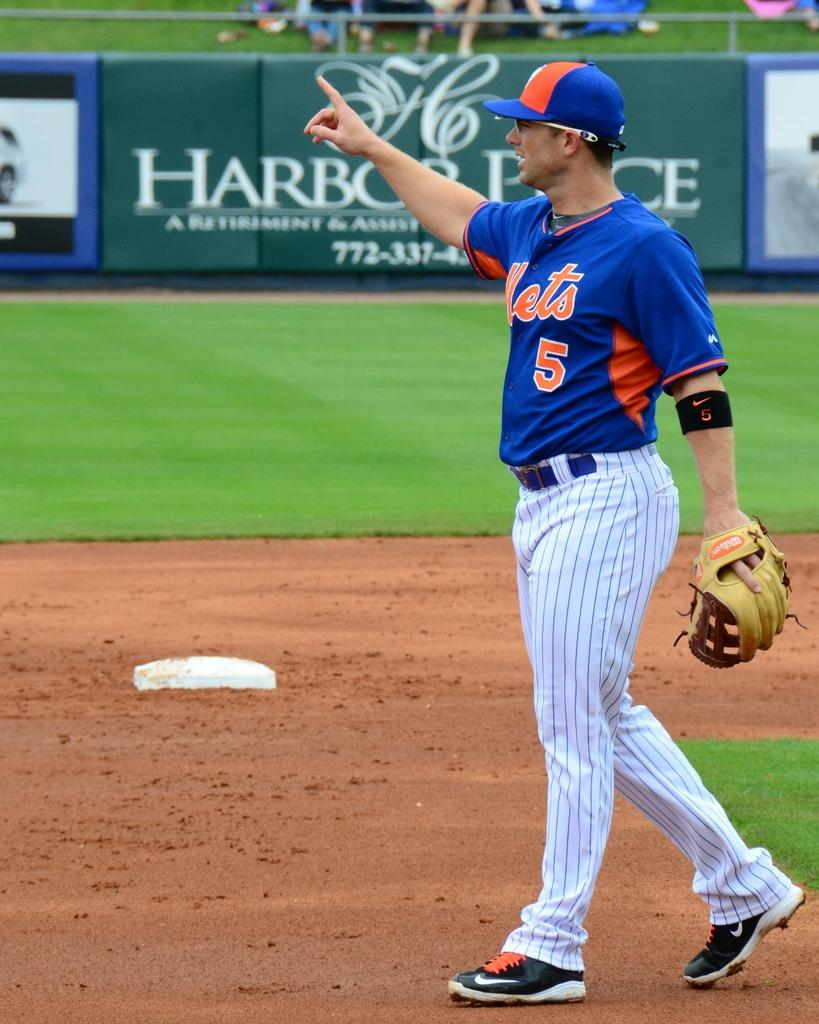<image>
Summarize the visual content of the image. a new york mets baseball player wearing the number 5 uniform shirt 